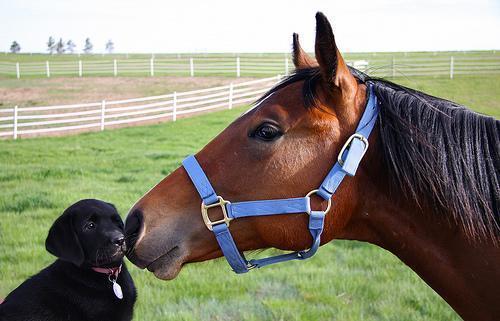How many animals are there?
Give a very brief answer. 2. 